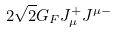<formula> <loc_0><loc_0><loc_500><loc_500>2 { \sqrt { 2 } } G _ { F } J _ { \mu } ^ { + } J ^ { \mu - }</formula> 